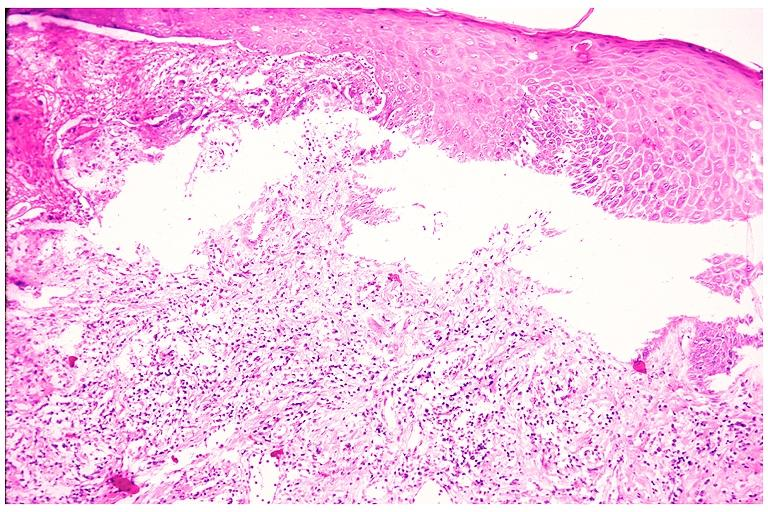where is this?
Answer the question using a single word or phrase. Oral 